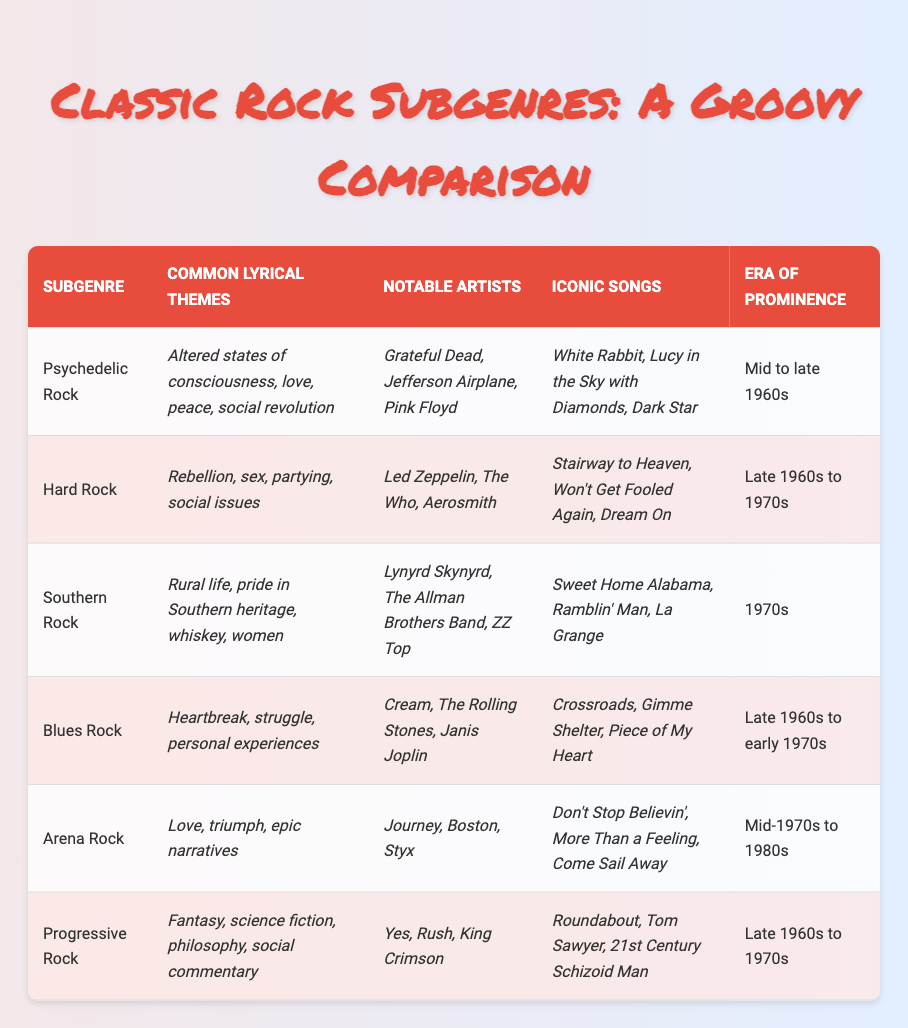What are the common lyrical themes associated with Southern Rock? By looking at the "Common Lyrical Themes" column, we can identify that Southern Rock often revolves around rural life, pride in Southern heritage, whiskey, and women.
Answer: Rural life, pride in Southern heritage, whiskey, women Which subgenre has iconic songs such as "Stairway to Heaven" and "Dream On"? From the "Iconic Songs" column, both “Stairway to Heaven” and “Dream On” are listed under Hard Rock.
Answer: Hard Rock True or False: The era of prominence for Arena Rock spans from the late 1960s to the 1970s. The "Era of Prominence" for Arena Rock is specifically stated as "Mid-1970s to 1980s," confirming that the statement is false.
Answer: False What are the notable artists associated with Blues Rock? The "Notable Artists" section indicates that Cream, The Rolling Stones, and Janis Joplin are prominent figures in the Blues Rock subgenre.
Answer: Cream, The Rolling Stones, Janis Joplin Which subgenre has a prominent lyrical theme of fantasy and science fiction? In the "Common Lyrical Themes" column, it states that Progressive Rock features themes of fantasy, science fiction, philosophy, and social commentary.
Answer: Progressive Rock Identify the subgenre known for its themes of rebellion, sex, and partying. By looking in the "Common Lyrical Themes" column, we find that these themes are characteristic of Hard Rock.
Answer: Hard Rock How many subgenres listed have a significant connection to the themes of love? Both Psychedelic Rock (love, peace), Arena Rock (love, triumph), and their respective themes indicate a connection to love, resulting in three subgenres.
Answer: 3 List the iconic song associated with Progressive Rock. Referring to the "Iconic Songs" column, "Roundabout," "Tom Sawyer," and "21st Century Schizoid Man" are all noted under Progressive Rock.
Answer: Roundabout, Tom Sawyer, 21st Century Schizoid Man What lyrical themes dominate the genre of Arena Rock? In the "Common Lyrical Themes" for Arena Rock, we find themes revolving around love, triumph, and epic narratives.
Answer: Love, triumph, epic narratives 